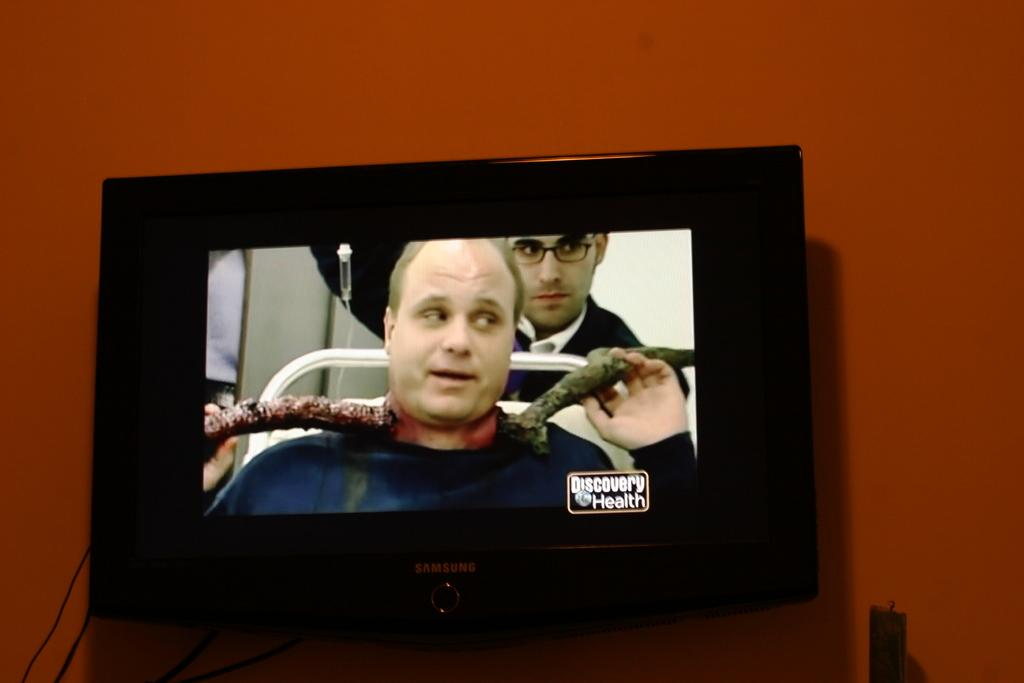Provide a one-sentence caption for the provided image. The tv is showing a program with the words discovery health on the bottom right. 